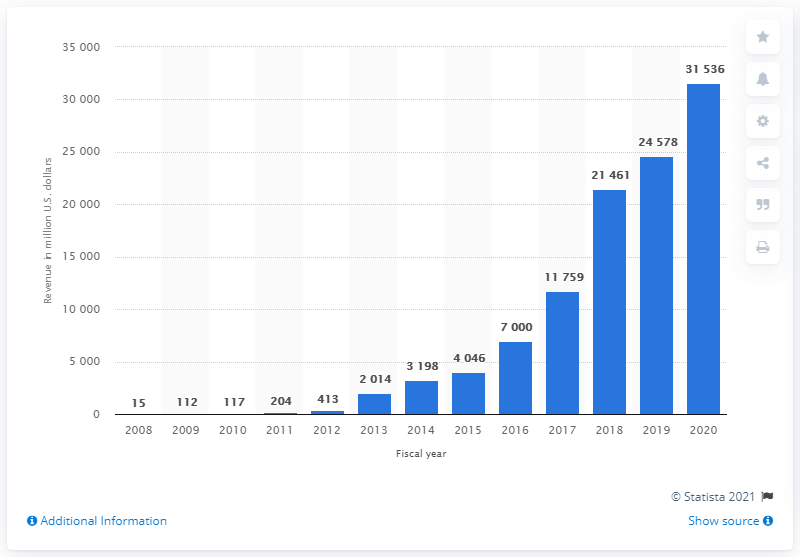Indicate a few pertinent items in this graphic. Tesla's revenue for the fiscal year of 2020 was approximately 31,536. 